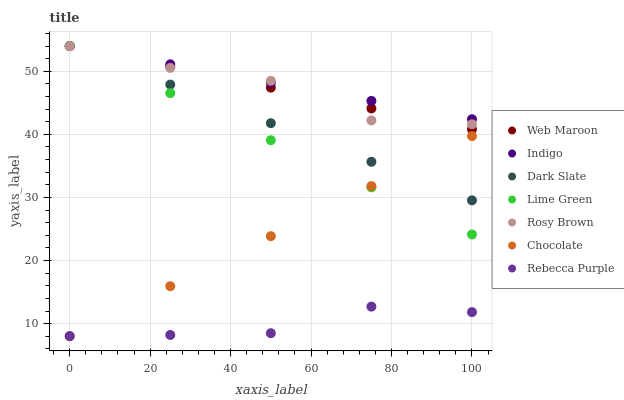Does Rebecca Purple have the minimum area under the curve?
Answer yes or no. Yes. Does Indigo have the maximum area under the curve?
Answer yes or no. Yes. Does Rosy Brown have the minimum area under the curve?
Answer yes or no. No. Does Rosy Brown have the maximum area under the curve?
Answer yes or no. No. Is Chocolate the smoothest?
Answer yes or no. Yes. Is Rosy Brown the roughest?
Answer yes or no. Yes. Is Web Maroon the smoothest?
Answer yes or no. No. Is Web Maroon the roughest?
Answer yes or no. No. Does Chocolate have the lowest value?
Answer yes or no. Yes. Does Rosy Brown have the lowest value?
Answer yes or no. No. Does Lime Green have the highest value?
Answer yes or no. Yes. Does Rosy Brown have the highest value?
Answer yes or no. No. Is Rebecca Purple less than Rosy Brown?
Answer yes or no. Yes. Is Dark Slate greater than Rebecca Purple?
Answer yes or no. Yes. Does Lime Green intersect Chocolate?
Answer yes or no. Yes. Is Lime Green less than Chocolate?
Answer yes or no. No. Is Lime Green greater than Chocolate?
Answer yes or no. No. Does Rebecca Purple intersect Rosy Brown?
Answer yes or no. No. 